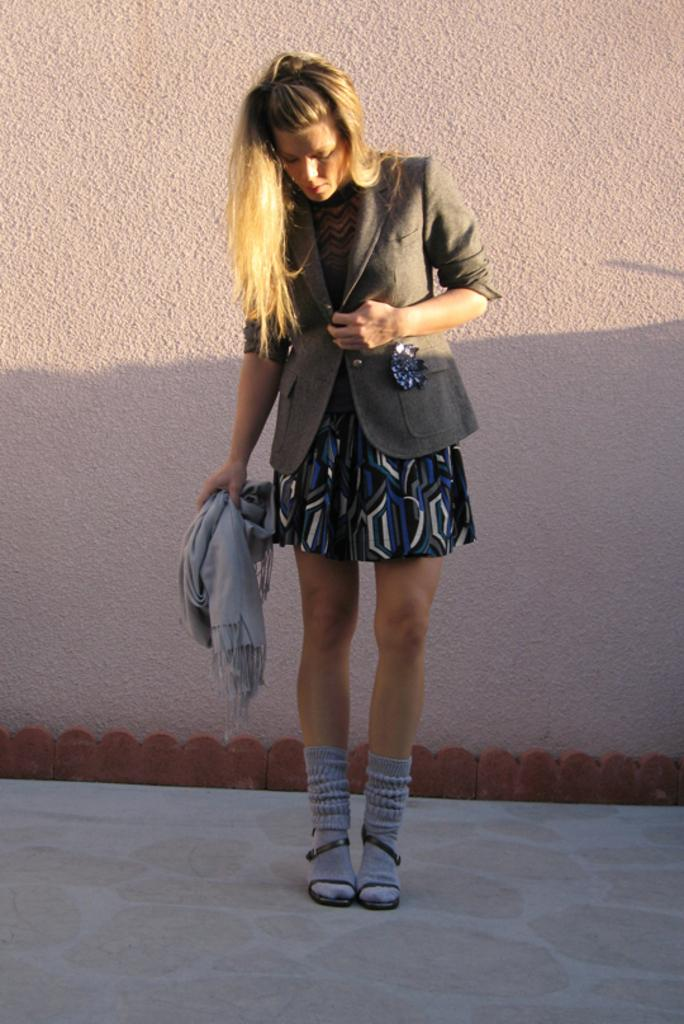Who is present in the image? There is a woman in the picture. What type of clothing is the woman wearing on her upper body? The woman is wearing a blazer. What color is the dress the woman is wearing? The woman is wearing a black dress. What type of footwear is the woman wearing? The woman is wearing shoes. What accessory is the woman holding? The woman is holding a scarf. Where is the woman positioned in the image? The woman is standing near a wall. How many servants are visible in the image? There are no servants present in the image; it features a woman wearing a blazer, black dress, shoes, and holding a scarf while standing near a wall. What type of sock is the woman wearing in the image? There is no mention of socks in the image; the woman is wearing shoes. 